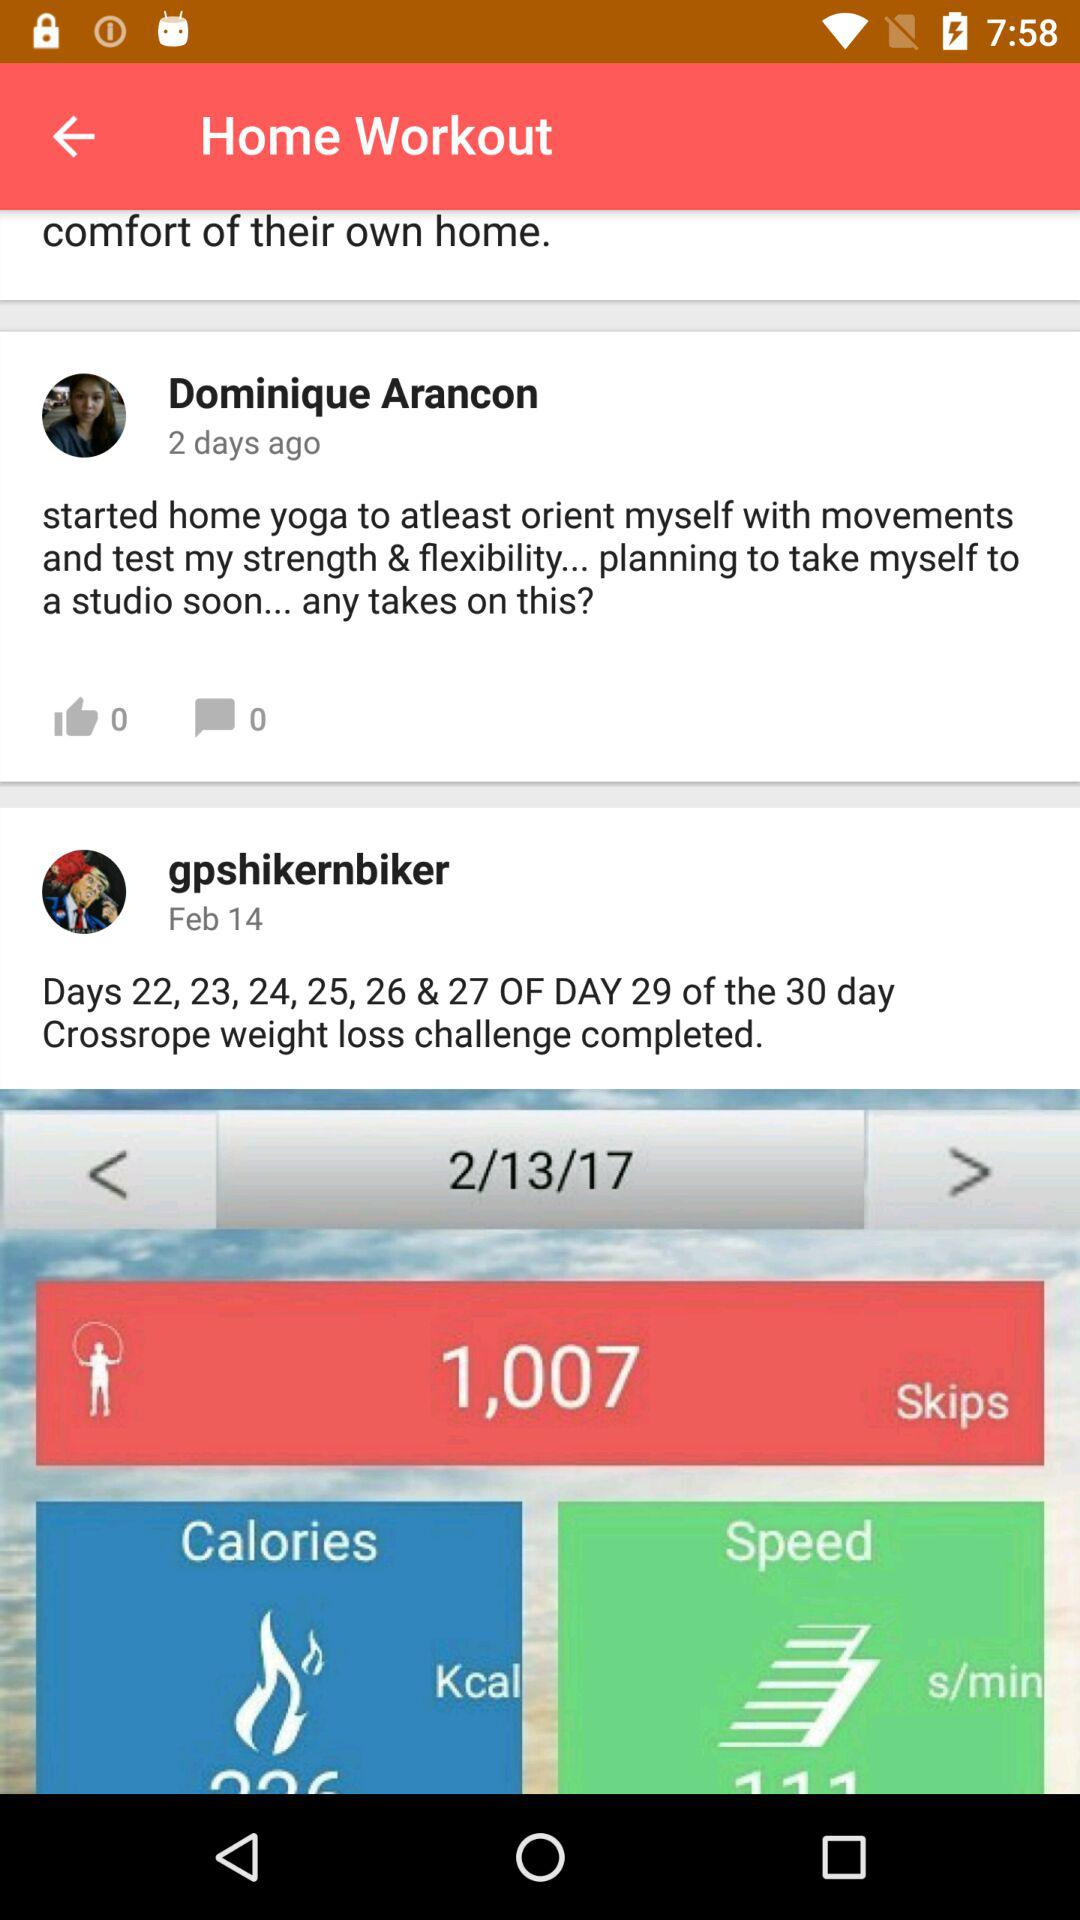How many skips in total are there? There are 1,007 skips. 